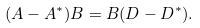<formula> <loc_0><loc_0><loc_500><loc_500>( A - A ^ { * } ) B = B ( D - D ^ { * } ) .</formula> 